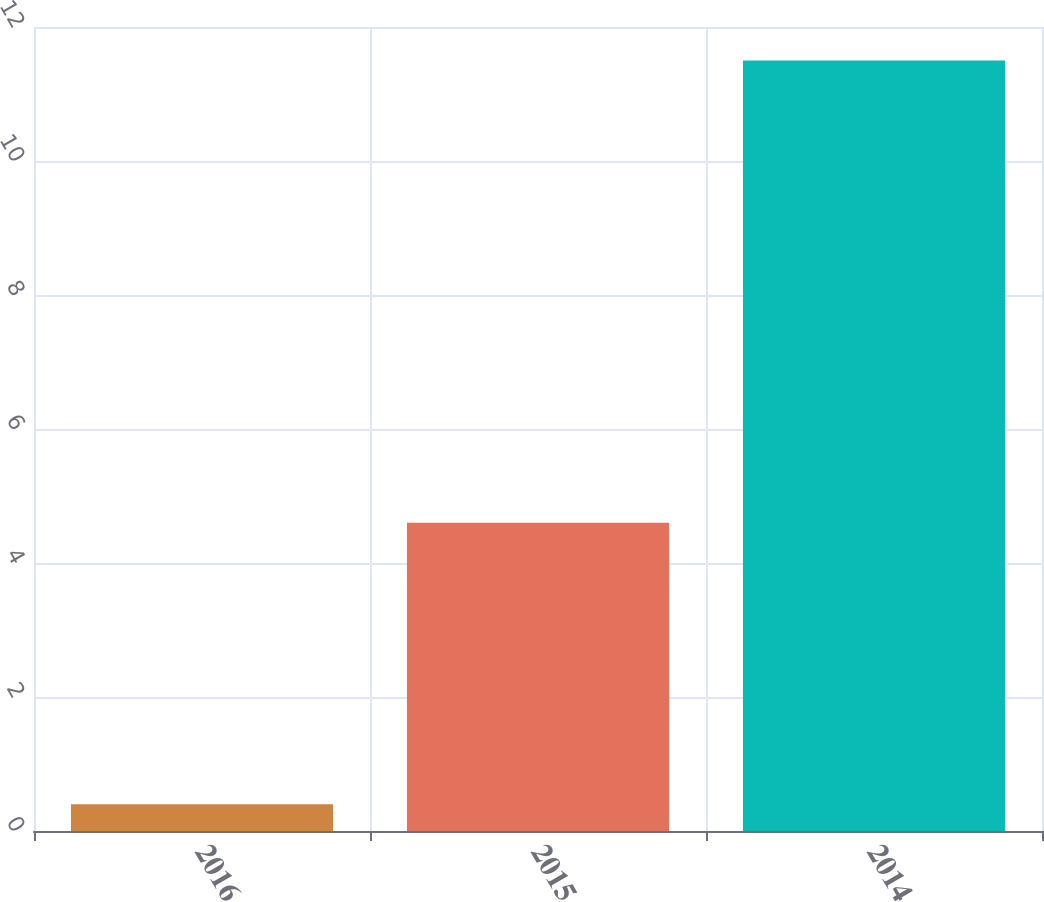Convert chart to OTSL. <chart><loc_0><loc_0><loc_500><loc_500><bar_chart><fcel>2016<fcel>2015<fcel>2014<nl><fcel>0.4<fcel>4.6<fcel>11.5<nl></chart> 